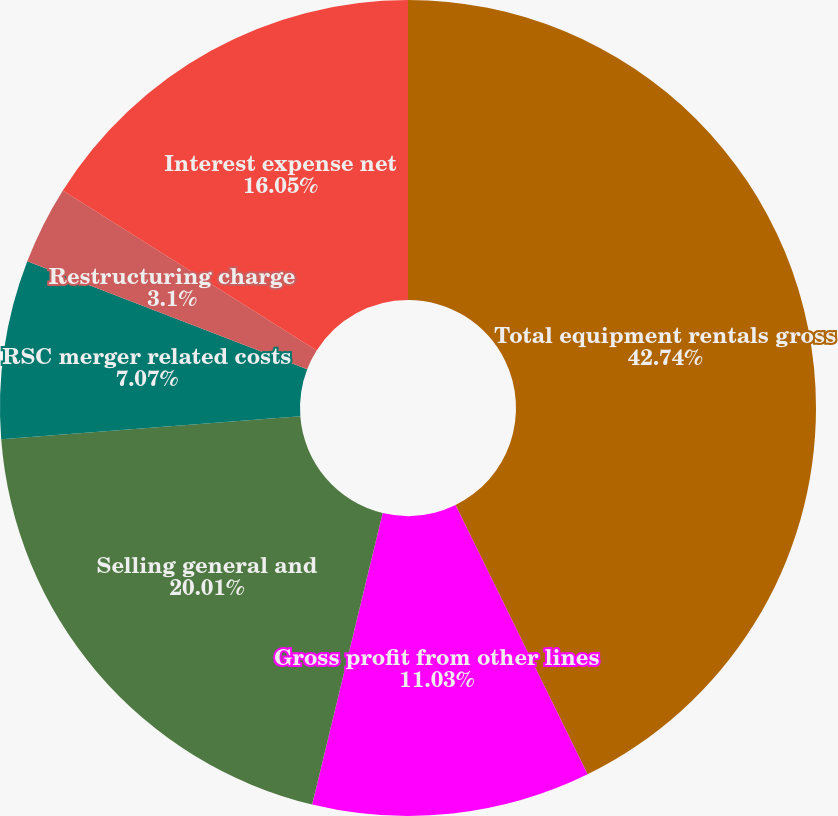Convert chart to OTSL. <chart><loc_0><loc_0><loc_500><loc_500><pie_chart><fcel>Total equipment rentals gross<fcel>Gross profit from other lines<fcel>Selling general and<fcel>RSC merger related costs<fcel>Restructuring charge<fcel>Interest expense net<nl><fcel>42.75%<fcel>11.03%<fcel>20.01%<fcel>7.07%<fcel>3.1%<fcel>16.05%<nl></chart> 